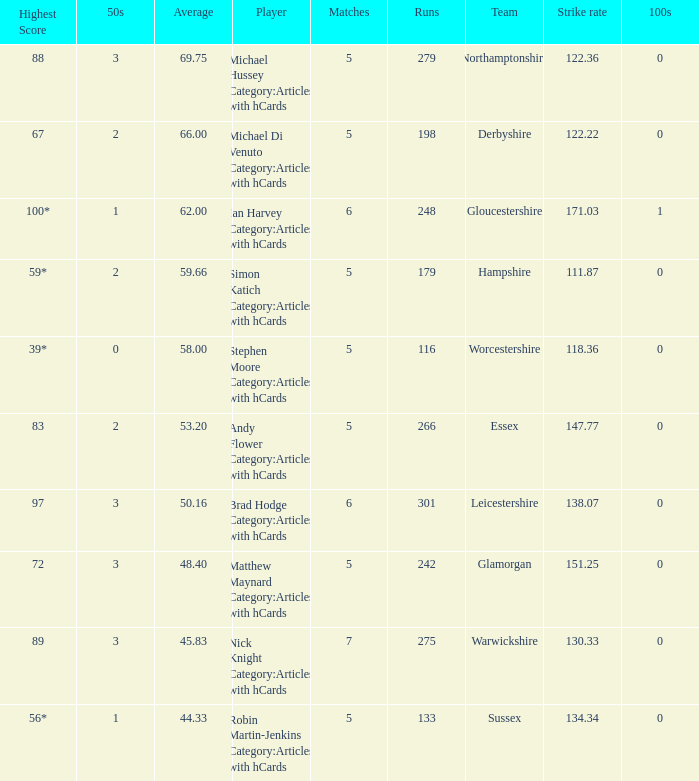If the team is Worcestershire and the Matched had were 5, what is the highest score? 39*. I'm looking to parse the entire table for insights. Could you assist me with that? {'header': ['Highest Score', '50s', 'Average', 'Player', 'Matches', 'Runs', 'Team', 'Strike rate', '100s'], 'rows': [['88', '3', '69.75', 'Michael Hussey Category:Articles with hCards', '5', '279', 'Northamptonshire', '122.36', '0'], ['67', '2', '66.00', 'Michael Di Venuto Category:Articles with hCards', '5', '198', 'Derbyshire', '122.22', '0'], ['100*', '1', '62.00', 'Ian Harvey Category:Articles with hCards', '6', '248', 'Gloucestershire', '171.03', '1'], ['59*', '2', '59.66', 'Simon Katich Category:Articles with hCards', '5', '179', 'Hampshire', '111.87', '0'], ['39*', '0', '58.00', 'Stephen Moore Category:Articles with hCards', '5', '116', 'Worcestershire', '118.36', '0'], ['83', '2', '53.20', 'Andy Flower Category:Articles with hCards', '5', '266', 'Essex', '147.77', '0'], ['97', '3', '50.16', 'Brad Hodge Category:Articles with hCards', '6', '301', 'Leicestershire', '138.07', '0'], ['72', '3', '48.40', 'Matthew Maynard Category:Articles with hCards', '5', '242', 'Glamorgan', '151.25', '0'], ['89', '3', '45.83', 'Nick Knight Category:Articles with hCards', '7', '275', 'Warwickshire', '130.33', '0'], ['56*', '1', '44.33', 'Robin Martin-Jenkins Category:Articles with hCards', '5', '133', 'Sussex', '134.34', '0']]} 